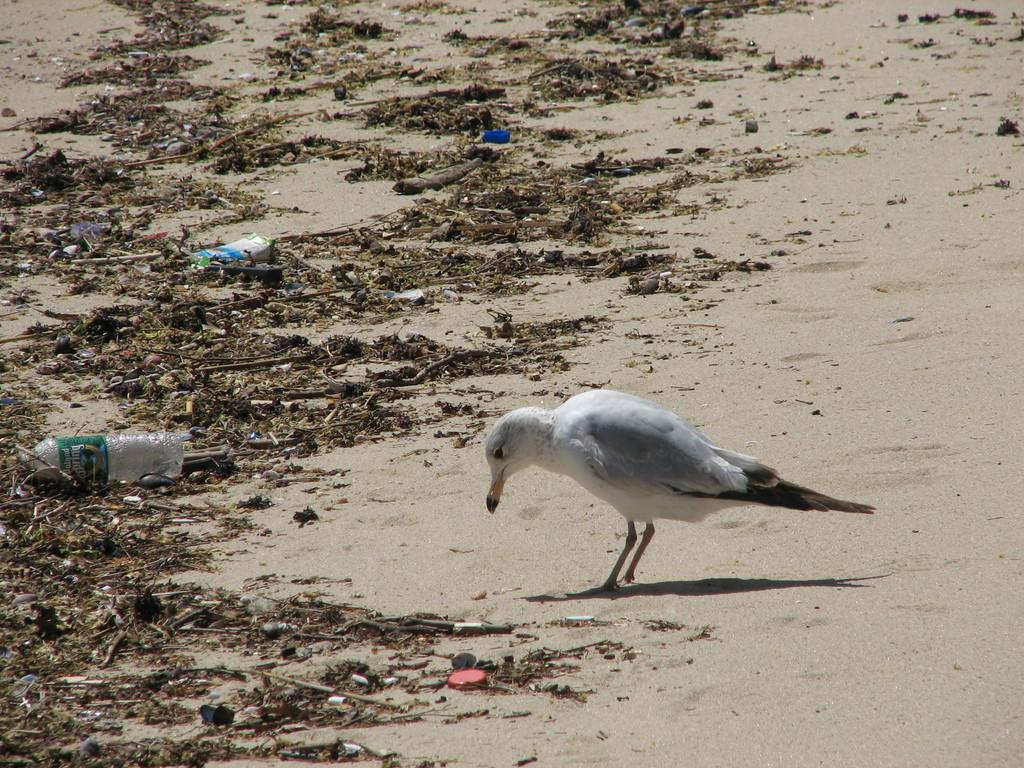What type of path is visible in the image? There is a sand path in the image. What can be seen in the air in the image? Dust is visible in the image. What animal is present in the image? There is a bird in the image. Where is the bird located in relation to the sand path? The bird is standing on the sand. What are the color characteristics of the bird? The bird has a white body and a black tail. Can you tell me how far the bird is from the zoo in the image? There is no information about a zoo or distance in the image, so it cannot be determined. What type of currency is being exchanged between the bird and the sand in the image? There is no exchange of currency or any transaction taking place in the image. 